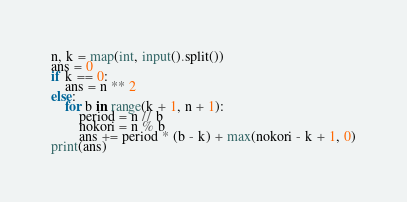<code> <loc_0><loc_0><loc_500><loc_500><_Python_>n, k = map(int, input().split())
ans = 0
if k == 0:
    ans = n ** 2
else:
    for b in range(k + 1, n + 1):
        period = n // b
        nokori = n % b
        ans += period * (b - k) + max(nokori - k + 1, 0)
print(ans)
</code> 